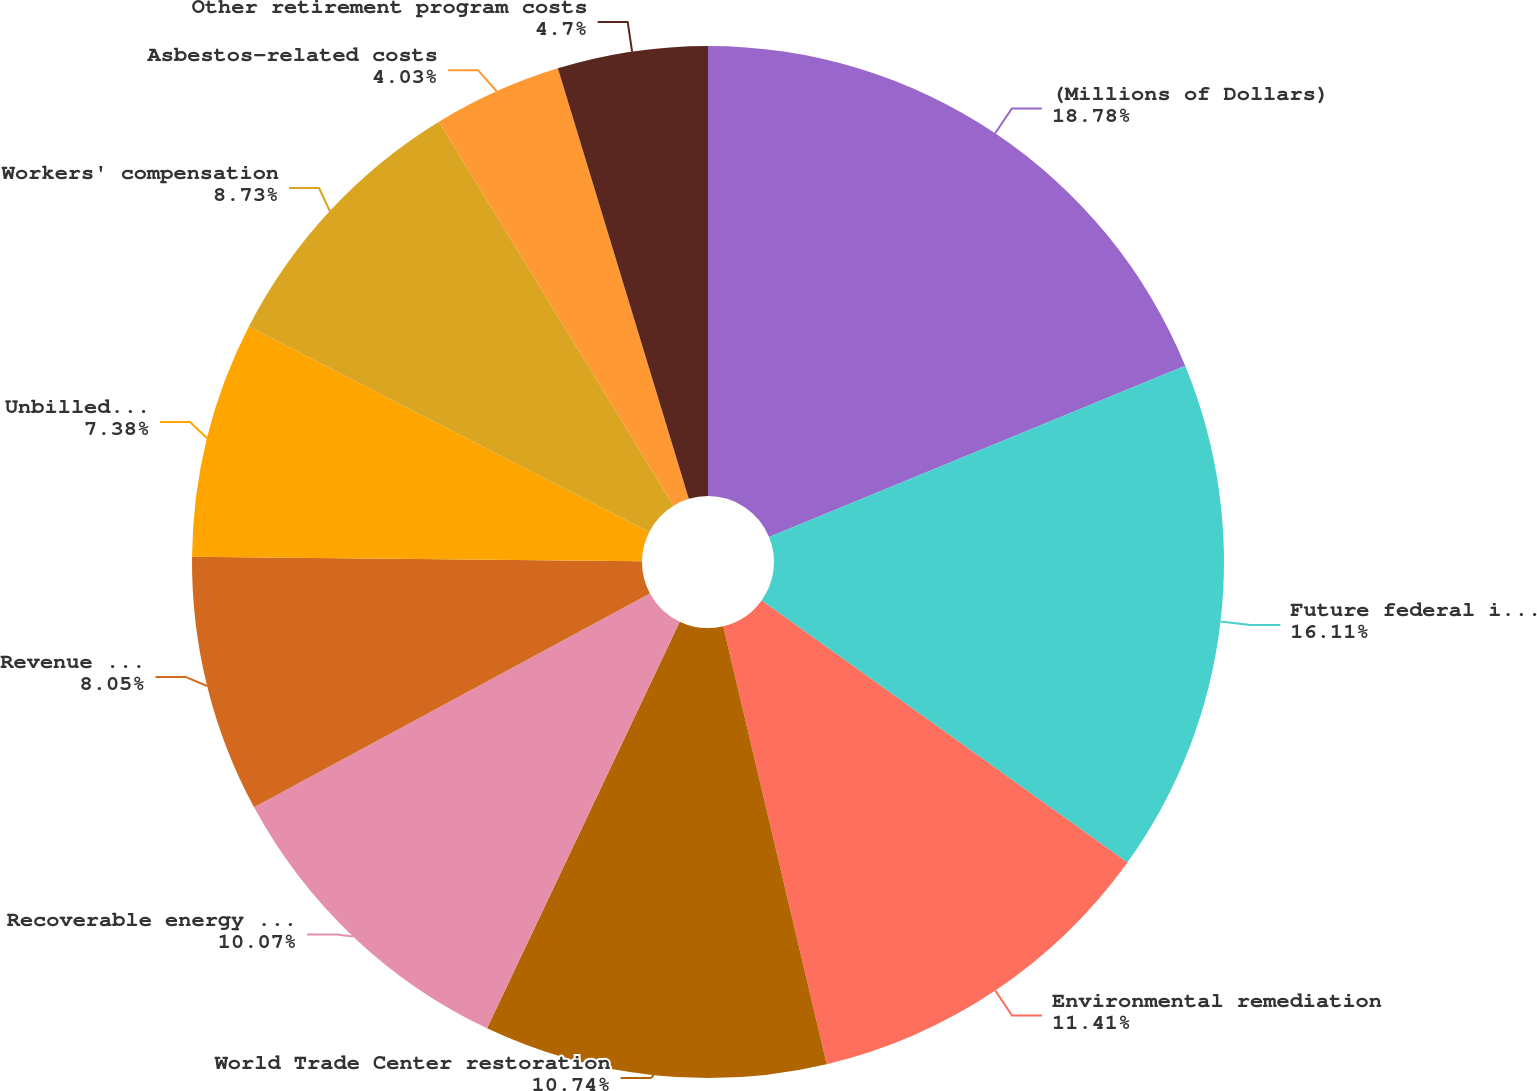Convert chart. <chart><loc_0><loc_0><loc_500><loc_500><pie_chart><fcel>(Millions of Dollars)<fcel>Future federal income tax<fcel>Environmental remediation<fcel>World Trade Center restoration<fcel>Recoverable energy costs<fcel>Revenue taxes<fcel>Unbilled gas revenue<fcel>Workers' compensation<fcel>Asbestos-related costs<fcel>Other retirement program costs<nl><fcel>18.79%<fcel>16.11%<fcel>11.41%<fcel>10.74%<fcel>10.07%<fcel>8.05%<fcel>7.38%<fcel>8.73%<fcel>4.03%<fcel>4.7%<nl></chart> 